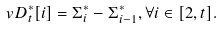<formula> <loc_0><loc_0><loc_500><loc_500>\ v D _ { t } ^ { * } [ i ] = \Sigma ^ { * } _ { i } - \Sigma ^ { * } _ { i - 1 } , \forall i \in [ 2 , t ] .</formula> 